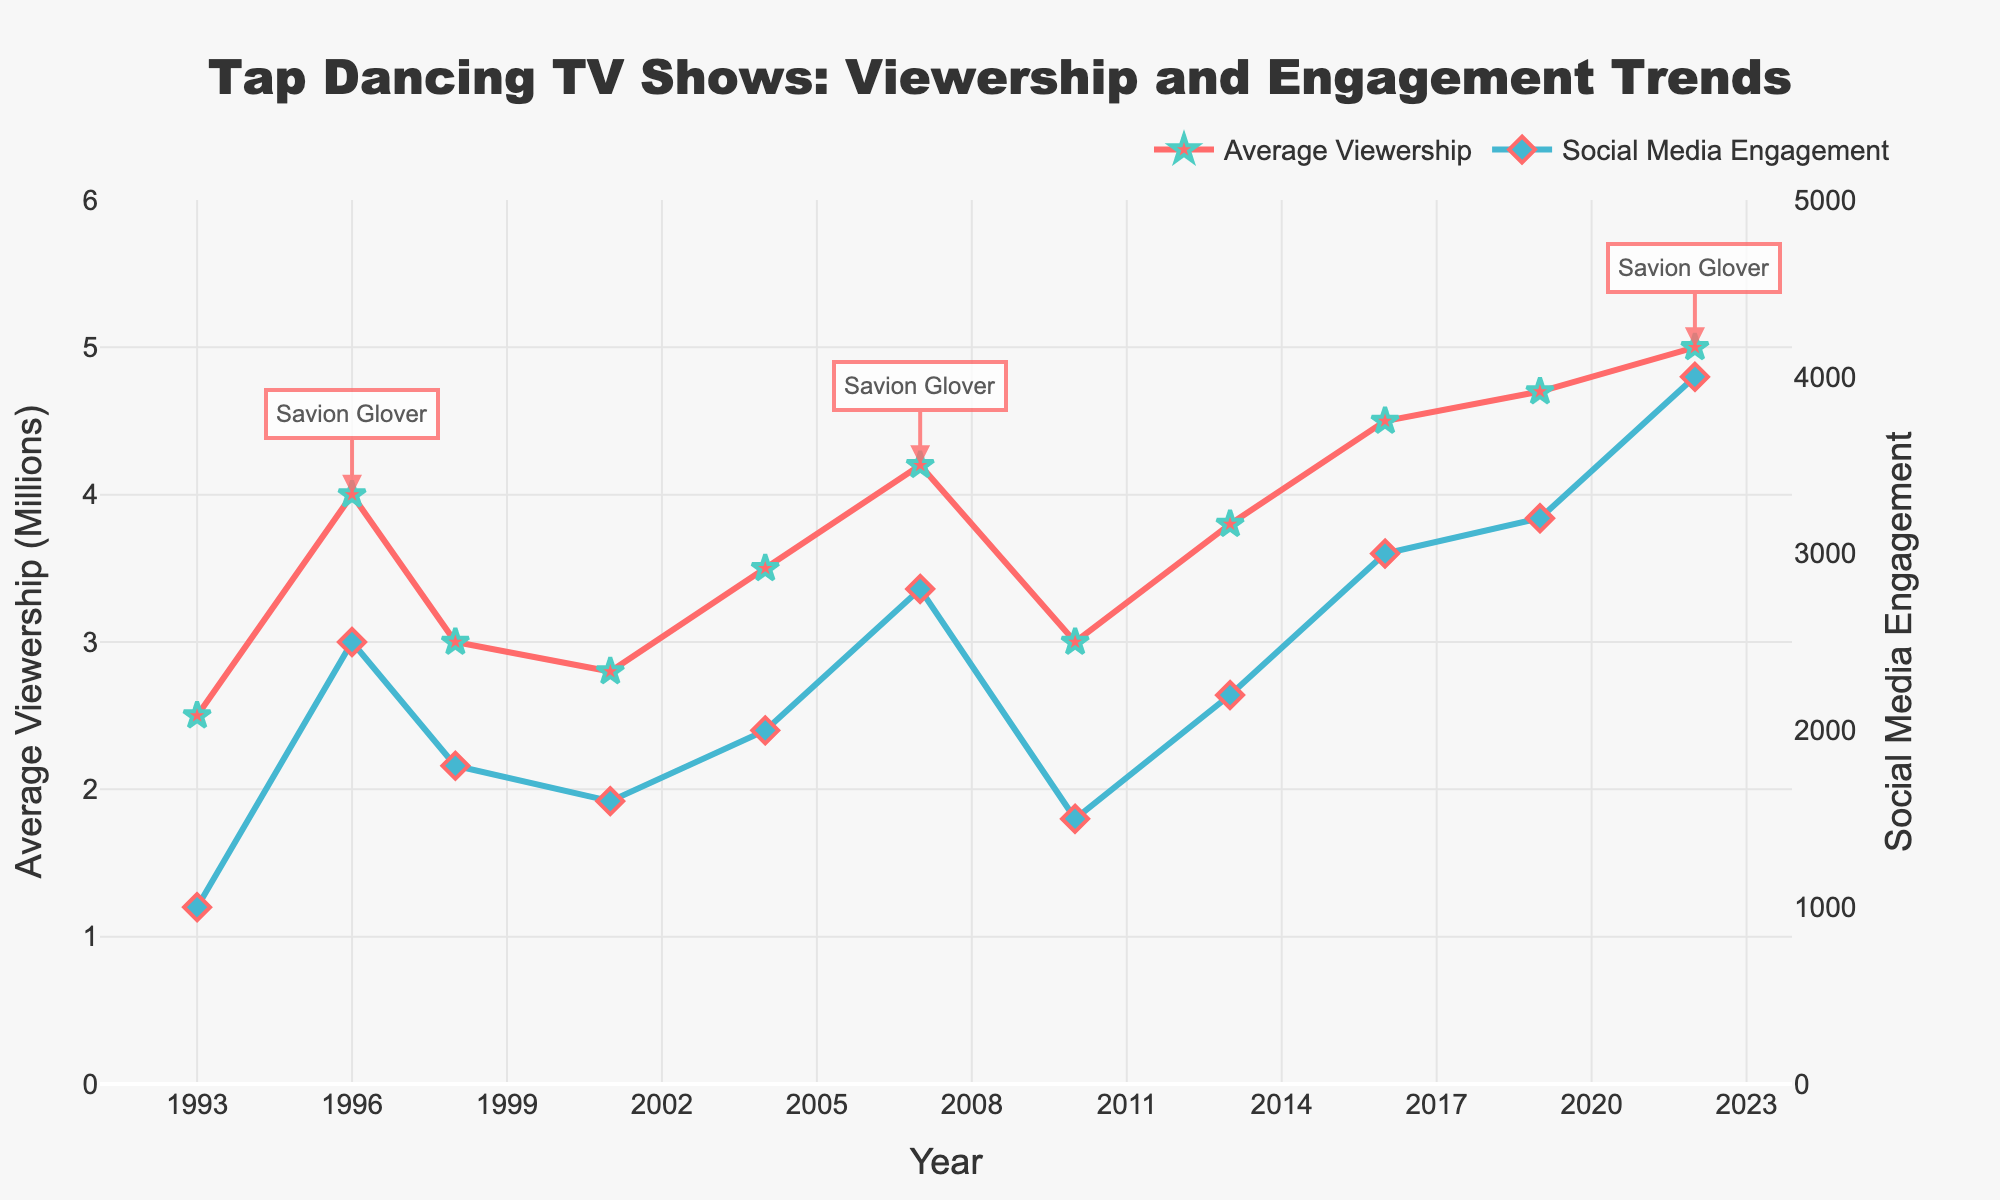What's the title of the plot? The title is typically found at the top center of the plot and summarizes the content. In this case, the title is indicated in the code.
Answer: Tap Dancing TV Shows: Viewership and Engagement Trends Which show's viewership is highest in the figure? Look for the peak data point in the series representing 'Average Viewership (Millions)', which is colored in red with markers. Locate the highest point and identify the associated show.
Answer: Savion Glover’s Tap Sensation In which year did Tapaholics air, and what was its average viewership? Locate the name 'Tapaholics' along the timeline, then check the corresponding year on the x-axis and the viewership on the y-axis.
Answer: 2001, 2.8 How did the viewership change from The Tap Masters (2013) to Tap World (2016)? Check the viewership values for both shows and calculate the difference: Tap World minus The Tap Masters.
Answer: Increase by 0.7 million Which show had the highest social media engagement and in what year? Look at the blue-colored line for markers and identify the peak engagement value, then check the corresponding year and show name.
Answer: Savion Glover’s Tap Sensation, 2022 Compare the trends of viewership and social media engagement from 1993 to 2022. Examine both lines over the years to see their general direction, peaks, and patterns.
Answer: Both trends generally increase over time, with more pronounced peaks in social media engagement in recent years How many shows are noted in the plot legend? Look at the legend on the right side of the plot for the total number of distinct show names listed.
Answer: Two (Average Viewership, Social Media Engagement) What is the average viewership for shows featuring Savion Glover? Extract the viewership numbers for shows with 'Savion Glover' in the title and calculate the average. Savion Glover’s shows (4.0, 4.2, 5.0). Sum = 13.2, Divide by 3.
Answer: 4.4 million Identify one compositional trend between viewership and social media engagement over time. Observing the simultaneous increase or decrease in both metrics over the years and explaining a compositional relationship.
Answer: Both metrics show coordinated increases, especially clear after 2010 when high engagement significantly corresponds to higher viewership 